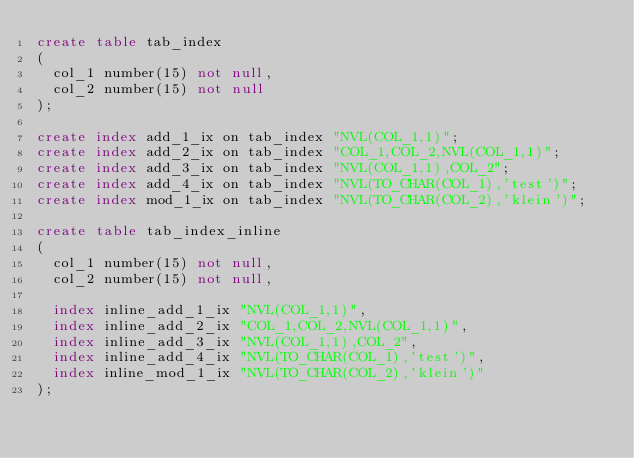<code> <loc_0><loc_0><loc_500><loc_500><_SQL_>create table tab_index
(
  col_1 number(15) not null,
  col_2 number(15) not null
);

create index add_1_ix on tab_index "NVL(COL_1,1)";
create index add_2_ix on tab_index "COL_1,COL_2,NVL(COL_1,1)";
create index add_3_ix on tab_index "NVL(COL_1,1),COL_2";
create index add_4_ix on tab_index "NVL(TO_CHAR(COL_1),'test')";
create index mod_1_ix on tab_index "NVL(TO_CHAR(COL_2),'klein')";

create table tab_index_inline
(
  col_1 number(15) not null,
  col_2 number(15) not null,

  index inline_add_1_ix "NVL(COL_1,1)",
  index inline_add_2_ix "COL_1,COL_2,NVL(COL_1,1)",
  index inline_add_3_ix "NVL(COL_1,1),COL_2",
  index inline_add_4_ix "NVL(TO_CHAR(COL_1),'test')",
  index inline_mod_1_ix "NVL(TO_CHAR(COL_2),'klein')"
);
</code> 